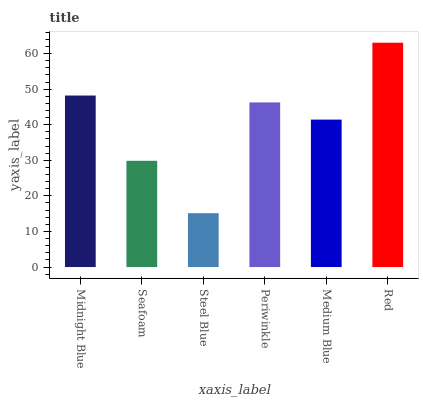Is Steel Blue the minimum?
Answer yes or no. Yes. Is Red the maximum?
Answer yes or no. Yes. Is Seafoam the minimum?
Answer yes or no. No. Is Seafoam the maximum?
Answer yes or no. No. Is Midnight Blue greater than Seafoam?
Answer yes or no. Yes. Is Seafoam less than Midnight Blue?
Answer yes or no. Yes. Is Seafoam greater than Midnight Blue?
Answer yes or no. No. Is Midnight Blue less than Seafoam?
Answer yes or no. No. Is Periwinkle the high median?
Answer yes or no. Yes. Is Medium Blue the low median?
Answer yes or no. Yes. Is Medium Blue the high median?
Answer yes or no. No. Is Red the low median?
Answer yes or no. No. 